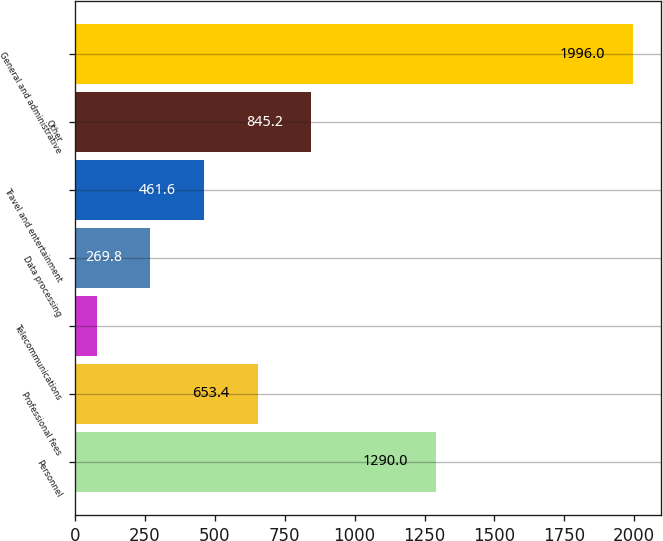<chart> <loc_0><loc_0><loc_500><loc_500><bar_chart><fcel>Personnel<fcel>Professional fees<fcel>Telecommunications<fcel>Data processing<fcel>Travel and entertainment<fcel>Other<fcel>General and administrative<nl><fcel>1290<fcel>653.4<fcel>78<fcel>269.8<fcel>461.6<fcel>845.2<fcel>1996<nl></chart> 